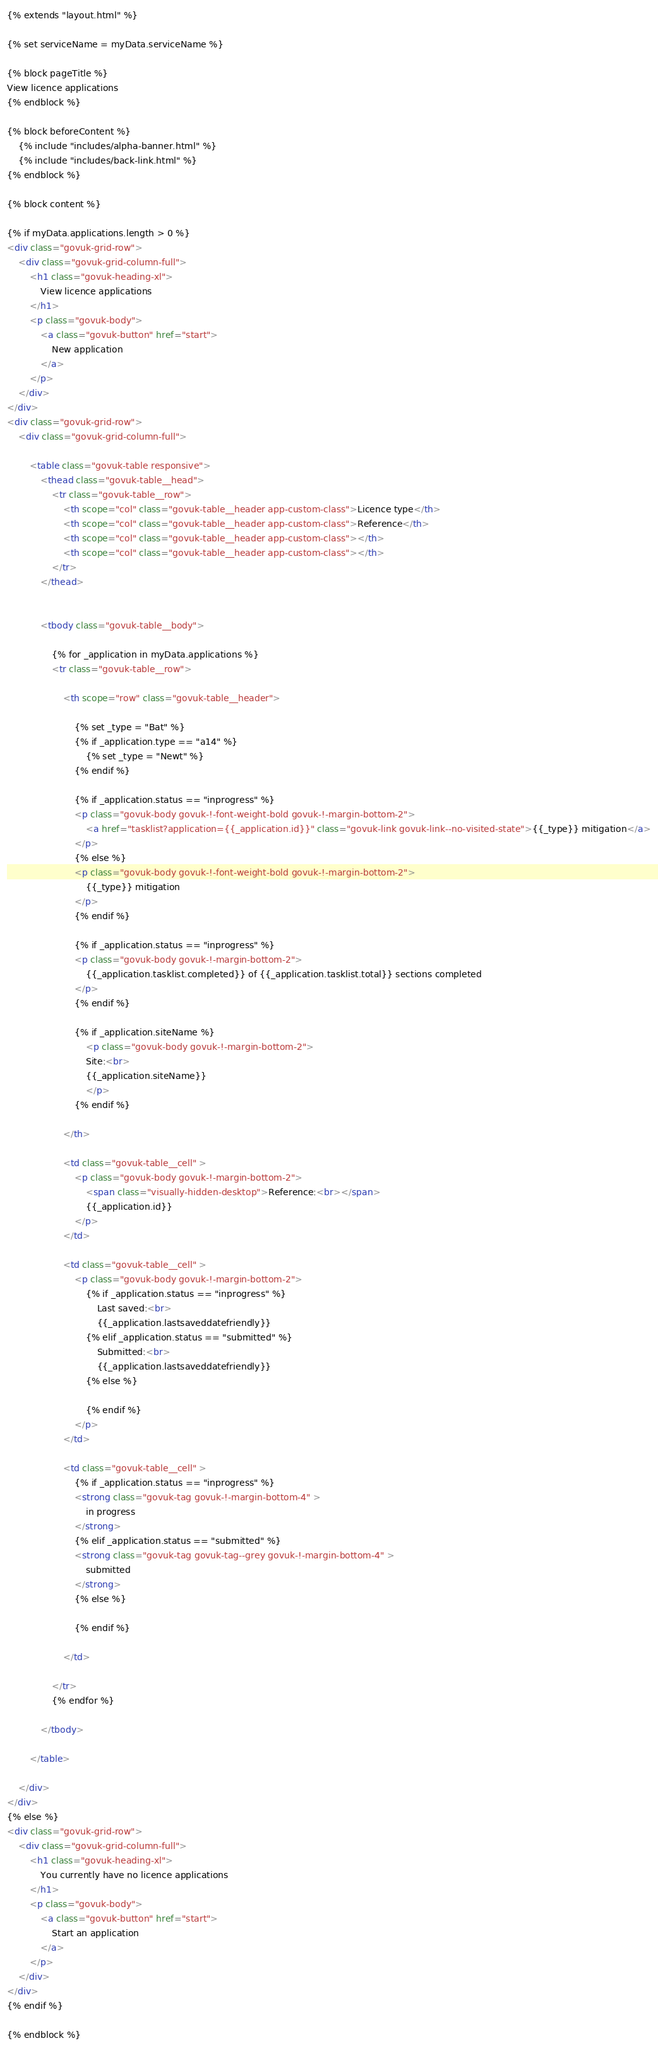<code> <loc_0><loc_0><loc_500><loc_500><_HTML_>{% extends "layout.html" %}

{% set serviceName = myData.serviceName %}

{% block pageTitle %} 
View licence applications
{% endblock %}

{% block beforeContent %}
    {% include "includes/alpha-banner.html" %}
    {% include "includes/back-link.html" %}
{% endblock %}

{% block content %}

{% if myData.applications.length > 0 %}
<div class="govuk-grid-row">
	<div class="govuk-grid-column-full">
        <h1 class="govuk-heading-xl">
            View licence applications
        </h1>
        <p class="govuk-body">
            <a class="govuk-button" href="start">
                New application
            </a>
        </p>
    </div>
</div>
<div class="govuk-grid-row">
	<div class="govuk-grid-column-full">
		
        <table class="govuk-table responsive">
            <thead class="govuk-table__head">
                <tr class="govuk-table__row">
                    <th scope="col" class="govuk-table__header app-custom-class">Licence type</th>
                    <th scope="col" class="govuk-table__header app-custom-class">Reference</th>
                    <th scope="col" class="govuk-table__header app-custom-class"></th>
                    <th scope="col" class="govuk-table__header app-custom-class"></th>
                </tr>
            </thead>
    
            
            <tbody class="govuk-table__body">

                {% for _application in myData.applications %}
                <tr class="govuk-table__row">

                    <th scope="row" class="govuk-table__header">

                        {% set _type = "Bat" %}
                        {% if _application.type == "a14" %}
                            {% set _type = "Newt" %}
                        {% endif %}

                        {% if _application.status == "inprogress" %}
                        <p class="govuk-body govuk-!-font-weight-bold govuk-!-margin-bottom-2">
                            <a href="tasklist?application={{_application.id}}" class="govuk-link govuk-link--no-visited-state">{{_type}} mitigation</a>
                        </p>
                        {% else %}
                        <p class="govuk-body govuk-!-font-weight-bold govuk-!-margin-bottom-2">
                            {{_type}} mitigation
                        </p>
                        {% endif %}

                        {% if _application.status == "inprogress" %}
                        <p class="govuk-body govuk-!-margin-bottom-2">
                            {{_application.tasklist.completed}} of {{_application.tasklist.total}} sections completed
                        </p>
                        {% endif %}

                        {% if _application.siteName %}
                            <p class="govuk-body govuk-!-margin-bottom-2">
                            Site:<br>
                            {{_application.siteName}}
                            </p>
                        {% endif %}

                    </th>

                    <td class="govuk-table__cell" >
                        <p class="govuk-body govuk-!-margin-bottom-2">
                            <span class="visually-hidden-desktop">Reference:<br></span>
                            {{_application.id}}
                        </p>
                    </td>

                    <td class="govuk-table__cell" >
                        <p class="govuk-body govuk-!-margin-bottom-2">
                            {% if _application.status == "inprogress" %}
                                Last saved:<br>
                                {{_application.lastsaveddatefriendly}}
                            {% elif _application.status == "submitted" %}
                                Submitted:<br>
                                {{_application.lastsaveddatefriendly}}
                            {% else %}
                                
                            {% endif %}
                        </p>
                    </td>

                    <td class="govuk-table__cell" >
                        {% if _application.status == "inprogress" %}
                        <strong class="govuk-tag govuk-!-margin-bottom-4" >
                            in progress
                        </strong>
                        {% elif _application.status == "submitted" %}
                        <strong class="govuk-tag govuk-tag--grey govuk-!-margin-bottom-4" >
                            submitted
                        </strong>
                        {% else %}

                        {% endif %}
                        
                    </td>

                </tr>
                {% endfor %}

            </tbody>

        </table>

	</div>
</div>
{% else %}
<div class="govuk-grid-row">
	<div class="govuk-grid-column-full">
        <h1 class="govuk-heading-xl">
            You currently have no licence applications
        </h1>
        <p class="govuk-body">
            <a class="govuk-button" href="start">
                Start an application
            </a>
        </p>
    </div>
</div>
{% endif %}

{% endblock %}</code> 